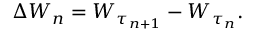Convert formula to latex. <formula><loc_0><loc_0><loc_500><loc_500>\Delta W _ { n } = W _ { \tau _ { n + 1 } } - W _ { \tau _ { n } } .</formula> 